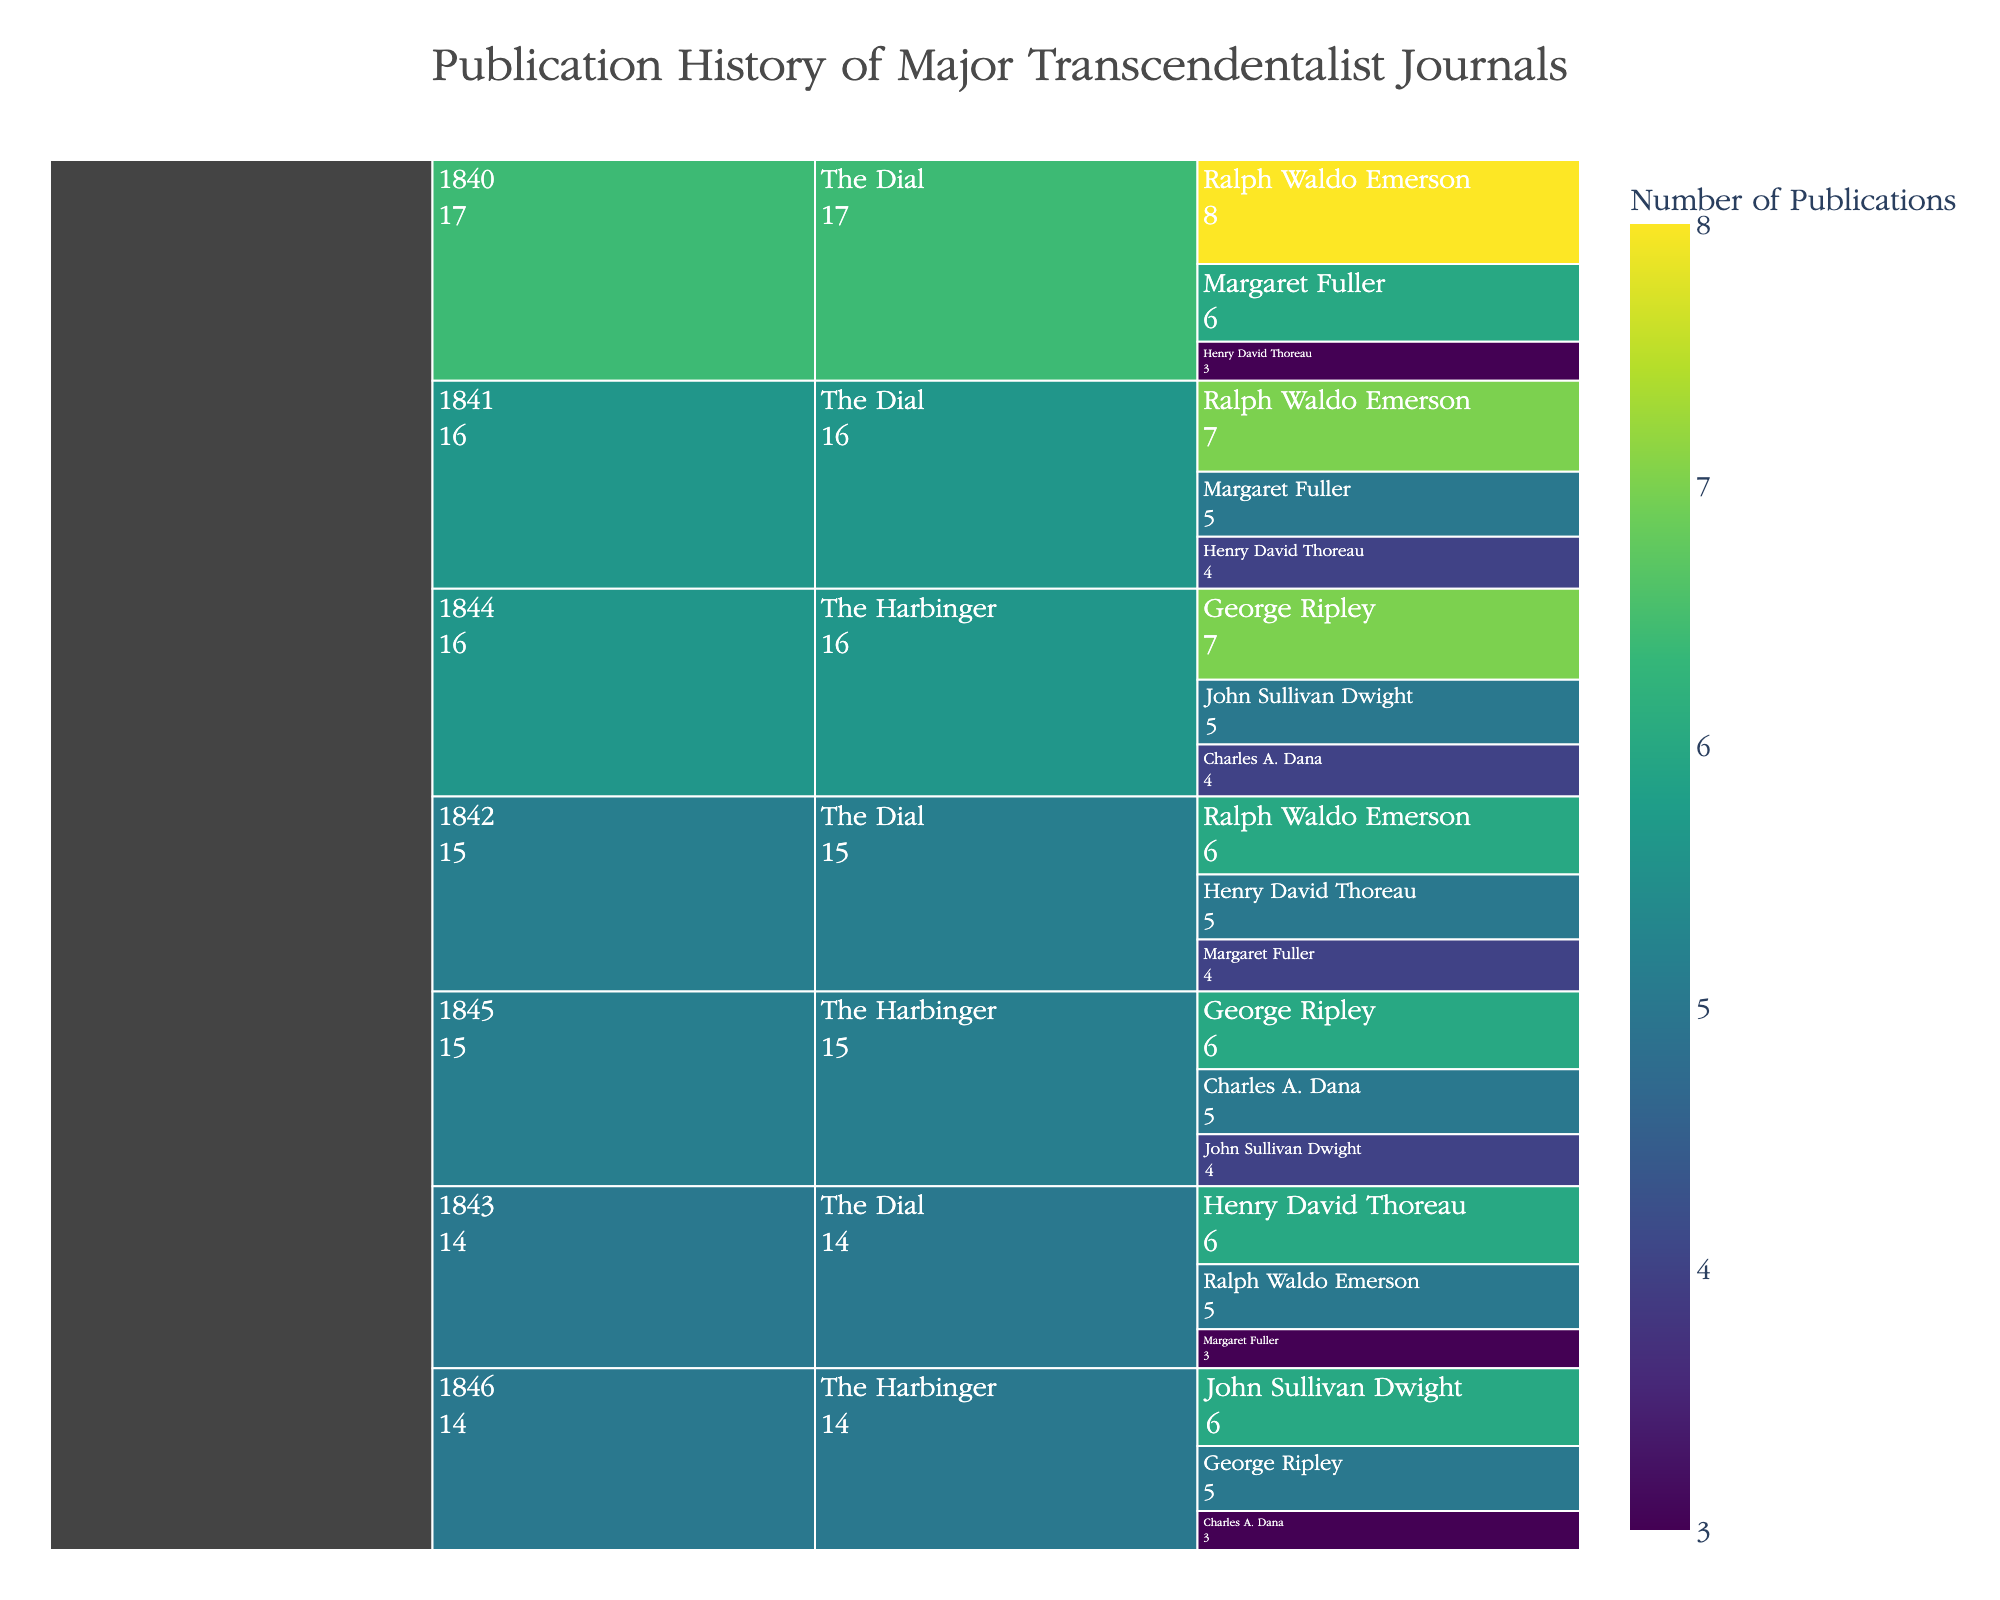what's the title of the chart? The title of the chart is visually presented at the top of the figure, usually in a larger and distinctive font compared to other text elements.
Answer: Publication History of Major Transcendentalist Journals Which contributor had the highest number of publications in The Dial in 1840? To find the contributor with the highest number of publications in The Dial in 1840, we need to look at the contributors listed under the year 1840 in the icicle chart and compare their publication counts. Ralph Waldo Emerson had 8 publications, Margaret Fuller had 6, and Henry David Thoreau had 3. The highest number is 8 by Ralph Waldo Emerson.
Answer: Ralph Waldo Emerson How many publications did The Harbinger have in 1844? We need to sum the publications of all contributors for The Harbinger in 1844. George Ripley had 7, John Sullivan Dwight had 5, and Charles A. Dana had 4. Summing these gives 7 + 5 + 4 = 16 publications.
Answer: 16 Which year saw the highest number of publications for The Dial? By examining the summaries provided for each year for The Dial in the icicle chart, we can sum the publication counts for Ralph Waldo Emerson, Margaret Fuller, and Henry David Thoreau for each year: for 1840 (8+6+3 = 17), for 1841 (7+5+4 = 16), for 1842 (6+4+5 = 15), and for 1843 (5+3+6 = 14). The highest total is 17, which occurred in 1840.
Answer: 1840 Compare the total number of publications by George Ripley and Henry David Thoreau across all years. Who contributed more? Summing George Ripley's publications from the figure: in 1844 (7), 1845 (6), and 1846 (5) gives 7 + 6 + 5 = 18. Summing Henry David Thoreau's publications: in 1840 (3), 1841 (4), 1842 (5), 1843 (6) gives 3 + 4 + 5 + 6 = 18. Both contributed an equal number of publications across all years.
Answer: Equal What was the average number of publications per year for Margaret Fuller in The Dial? We need to total Margaret Fuller's publications across the relevant years and then divide by the number of years she contributed. Her publications in The Dial are: in 1840 (6), 1841 (5), 1842 (4), 1843 (3). Summing these gives 6 + 5 + 4 + 3 = 18, spread over 4 years, so the average is 18 / 4 = 4.5.
Answer: 4.5 Which contributor had the lowest number of publications in The Harbinger in 1845? Checking the publication numbers for The Harbinger in 1845, George Ripley had 6, John Sullivan Dwight had 4, and Charles A. Dana had 5. The lowest number is 4 by John Sullivan Dwight.
Answer: John Sullivan Dwight Did contributors in The Dial have more publications in 1842 or 1843? We sum the total publications for both years. In 1842: Ralph Waldo Emerson (6), Margaret Fuller (4), Henry David Thoreau (5) giving 6 + 4 + 5 = 15. In 1843: Ralph Waldo Emerson (5), Margaret Fuller (3), Henry David Thoreau (6) giving 5 + 3 + 6 = 14. 1842 had more publications.
Answer: 1842 